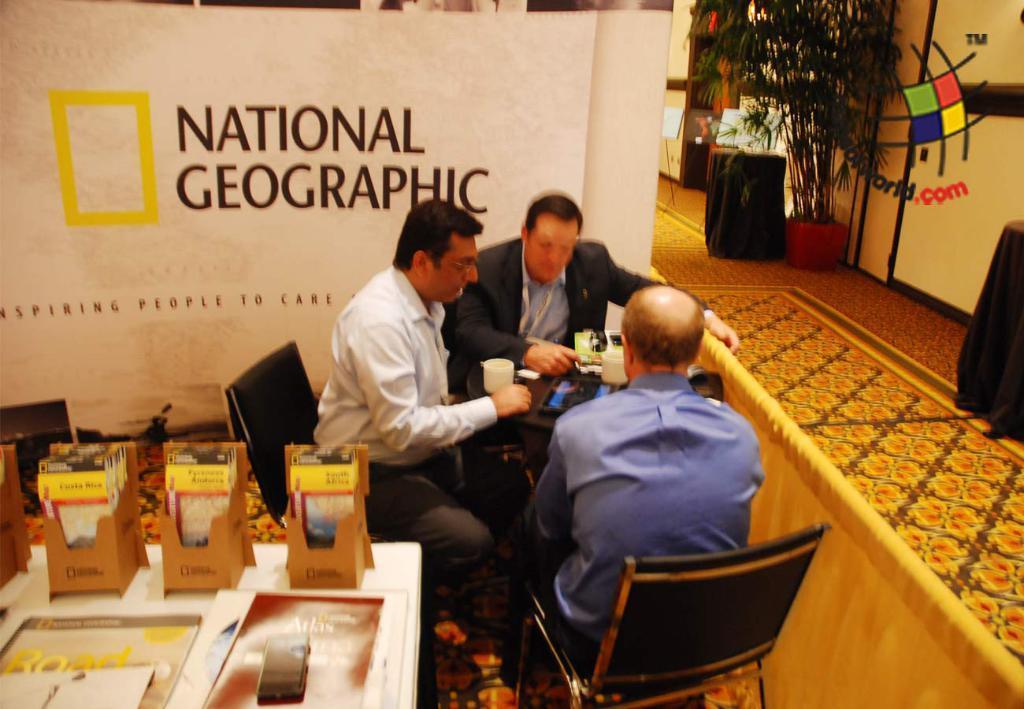Please provide a concise description of this image. In the picture I can see these people are sitting on the chairs near the table where we can see some objects are placed, I can see some cards are placed on a white color table which is on the left side of the image. In the background, I can see banners, flower pot and few more objects on the floor. 